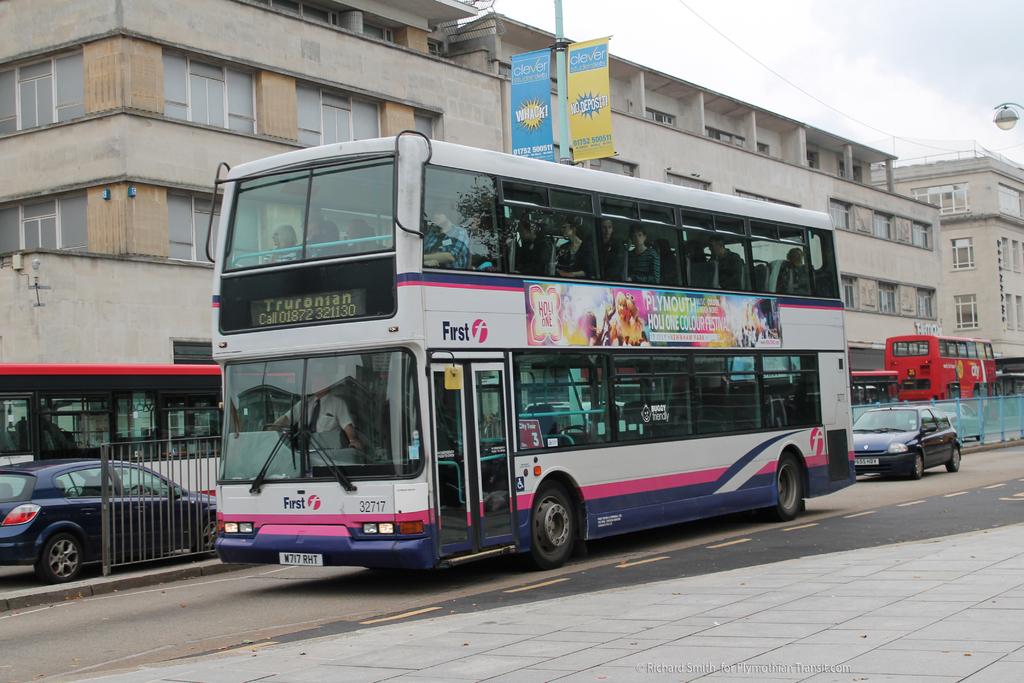Wher is this bus headed?
Offer a very short reply. Truronian. What is the word above the door on this bus?
Give a very brief answer. First. 